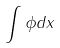<formula> <loc_0><loc_0><loc_500><loc_500>\int \phi d x</formula> 